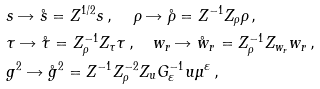Convert formula to latex. <formula><loc_0><loc_0><loc_500><loc_500>& s \rightarrow { \mathring { s } } = Z ^ { 1 / 2 } s \, , \quad \, \rho \rightarrow { \mathring { \rho } } = Z ^ { - 1 } Z _ { \rho } \rho \, , \\ & \tau \rightarrow { \mathring { \tau } } = Z _ { \rho } ^ { - 1 } Z _ { \tau } \tau \, , \quad w _ { r } \rightarrow \mathring { w } { _ { r } } = Z _ { \rho } ^ { - 1 } Z _ { w _ { r } } w _ { r } \, , \\ & g ^ { 2 } \rightarrow { \mathring { g } } ^ { 2 } = Z ^ { - 1 } Z _ { \rho } ^ { - 2 } Z _ { u } G _ { \varepsilon } ^ { - 1 } u \mu ^ { \varepsilon } \, ,</formula> 